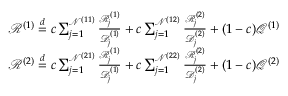Convert formula to latex. <formula><loc_0><loc_0><loc_500><loc_500>\begin{array} { r } { \mathcal { R } ^ { ( 1 ) } \stackrel { d } { = } c \sum _ { j = 1 } ^ { \mathcal { N } ^ { ( 1 1 ) } } \frac { \mathcal { R } _ { j } ^ { ( 1 ) } } { \mathcal { D } _ { j } ^ { ( 1 ) } } + c \sum _ { j = 1 } ^ { \mathcal { N } ^ { ( 1 2 ) } } \frac { \mathcal { R } _ { j } ^ { ( 2 ) } } { \mathcal { D } _ { j } ^ { ( 2 ) } } + ( 1 - c ) \mathcal { Q } ^ { ( 1 ) } } \\ { \mathcal { R } ^ { ( 2 ) } \stackrel { d } { = } c \sum _ { j = 1 } ^ { \mathcal { N } ^ { ( 2 1 ) } } \frac { \mathcal { R } _ { j } ^ { ( 1 ) } } { \mathcal { D } _ { j } ^ { ( 1 ) } } + c \sum _ { j = 1 } ^ { \mathcal { N } ^ { ( 2 2 ) } } \frac { \mathcal { R } _ { j } ^ { ( 2 ) } } { \mathcal { D } _ { j } ^ { ( 2 ) } } + ( 1 - c ) \mathcal { Q } ^ { ( 2 ) } } \end{array}</formula> 